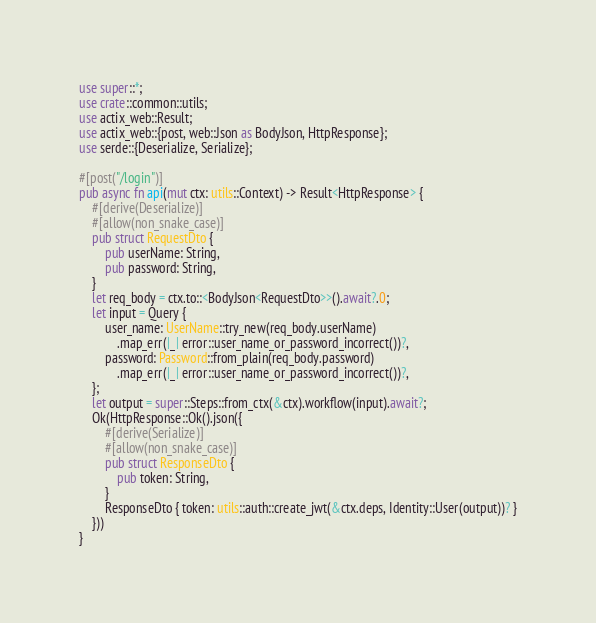Convert code to text. <code><loc_0><loc_0><loc_500><loc_500><_Rust_>use super::*;
use crate::common::utils;
use actix_web::Result;
use actix_web::{post, web::Json as BodyJson, HttpResponse};
use serde::{Deserialize, Serialize};

#[post("/login")]
pub async fn api(mut ctx: utils::Context) -> Result<HttpResponse> {
    #[derive(Deserialize)]
    #[allow(non_snake_case)]
    pub struct RequestDto {
        pub userName: String,
        pub password: String,
    }
    let req_body = ctx.to::<BodyJson<RequestDto>>().await?.0;
    let input = Query {
        user_name: UserName::try_new(req_body.userName)
            .map_err(|_| error::user_name_or_password_incorrect())?,
        password: Password::from_plain(req_body.password)
            .map_err(|_| error::user_name_or_password_incorrect())?,
    };
    let output = super::Steps::from_ctx(&ctx).workflow(input).await?;
    Ok(HttpResponse::Ok().json({
        #[derive(Serialize)]
        #[allow(non_snake_case)]
        pub struct ResponseDto {
            pub token: String,
        }
        ResponseDto { token: utils::auth::create_jwt(&ctx.deps, Identity::User(output))? }
    }))
}
</code> 